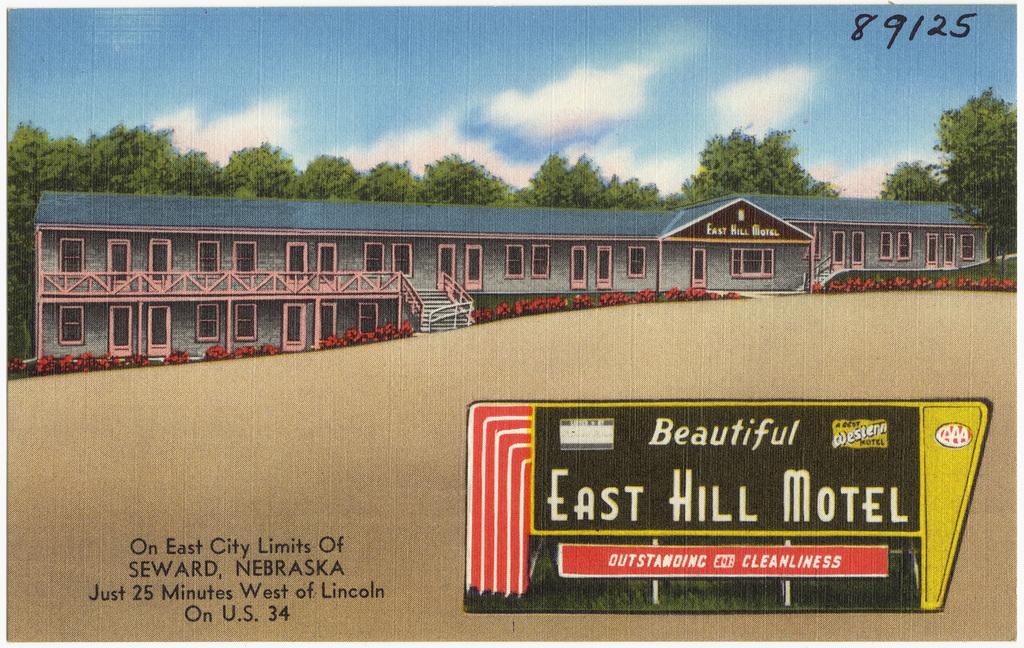What motel is this?
Your response must be concise. East hill motel. Whats the address of the motel?
Give a very brief answer. Seward, nebraska. 